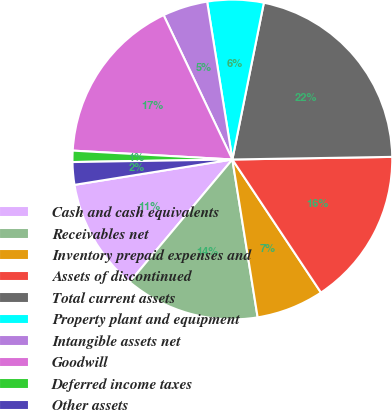<chart> <loc_0><loc_0><loc_500><loc_500><pie_chart><fcel>Cash and cash equivalents<fcel>Receivables net<fcel>Inventory prepaid expenses and<fcel>Assets of discontinued<fcel>Total current assets<fcel>Property plant and equipment<fcel>Intangible assets net<fcel>Goodwill<fcel>Deferred income taxes<fcel>Other assets<nl><fcel>11.36%<fcel>13.63%<fcel>6.82%<fcel>15.91%<fcel>21.58%<fcel>5.68%<fcel>4.55%<fcel>17.04%<fcel>1.14%<fcel>2.28%<nl></chart> 